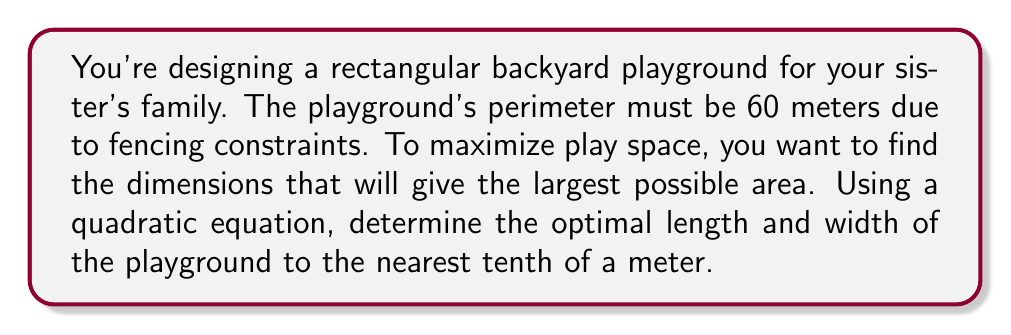Can you solve this math problem? Let's approach this step-by-step:

1) Let $x$ be the width and $y$ be the length of the playground.

2) Given that the perimeter is 60 meters, we can write:
   $2x + 2y = 60$

3) Solving for $y$:
   $y = 30 - x$

4) The area $A$ of the playground is given by:
   $A = xy = x(30-x) = 30x - x^2$

5) This is a quadratic function. To find the maximum area, we need to find the vertex of this parabola.

6) The general form of a quadratic function is $f(x) = ax^2 + bx + c$
   In our case, $a = -1$, $b = 30$, and $c = 0$

7) The x-coordinate of the vertex is given by $x = -\frac{b}{2a}$
   $x = -\frac{30}{2(-1)} = 15$

8) Therefore, the optimal width is 15 meters.

9) To find the length, substitute $x = 15$ into the equation from step 3:
   $y = 30 - 15 = 15$

10) To verify, we can calculate the perimeter:
    $2(15) + 2(15) = 60$ meters, which matches our constraint.

11) The maximum area is:
    $A = 15 * 15 = 225$ square meters

Therefore, the optimal dimensions are 15.0 meters by 15.0 meters.
Answer: The optimal dimensions of the playground are 15.0 meters in width and 15.0 meters in length. 